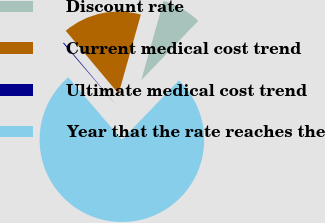<chart> <loc_0><loc_0><loc_500><loc_500><pie_chart><fcel>Discount rate<fcel>Current medical cost trend<fcel>Ultimate medical cost trend<fcel>Year that the rate reaches the<nl><fcel>7.82%<fcel>15.46%<fcel>0.19%<fcel>76.53%<nl></chart> 